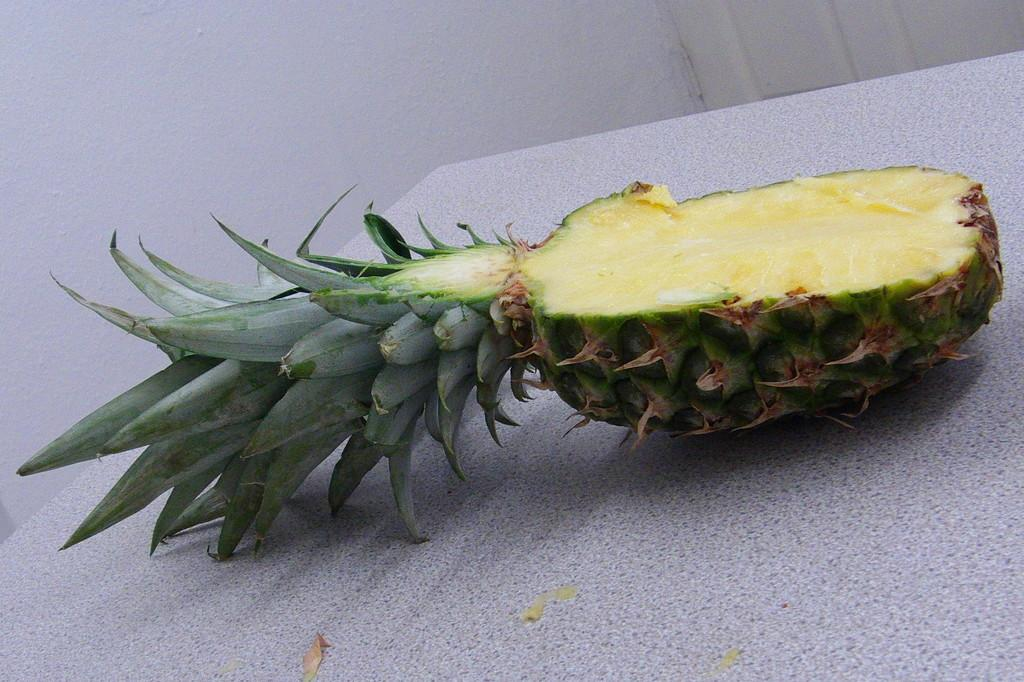What fruit is present on the table in the image? There is a pineapple on the table in the image. What can be seen in the background of the image? There is a wall visible in the image. What type of education is being offered in the wilderness in the image? There is no indication of education or wilderness in the image; it only features a pineapple on a table and a wall in the background. 